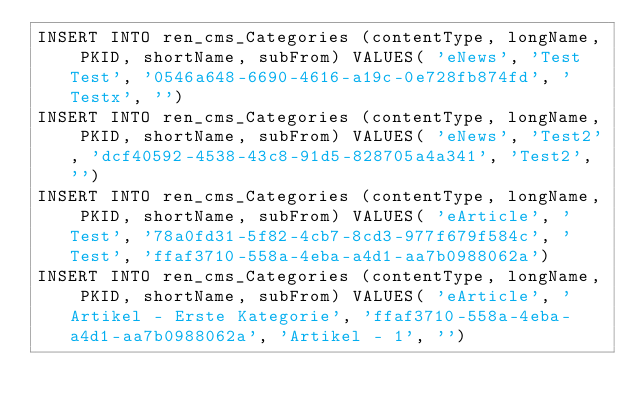Convert code to text. <code><loc_0><loc_0><loc_500><loc_500><_SQL_>INSERT INTO ren_cms_Categories (contentType, longName, PKID, shortName, subFrom) VALUES( 'eNews', 'Test Test', '0546a648-6690-4616-a19c-0e728fb874fd', 'Testx', '')
INSERT INTO ren_cms_Categories (contentType, longName, PKID, shortName, subFrom) VALUES( 'eNews', 'Test2', 'dcf40592-4538-43c8-91d5-828705a4a341', 'Test2', '')
INSERT INTO ren_cms_Categories (contentType, longName, PKID, shortName, subFrom) VALUES( 'eArticle', 'Test', '78a0fd31-5f82-4cb7-8cd3-977f679f584c', 'Test', 'ffaf3710-558a-4eba-a4d1-aa7b0988062a')
INSERT INTO ren_cms_Categories (contentType, longName, PKID, shortName, subFrom) VALUES( 'eArticle', 'Artikel - Erste Kategorie', 'ffaf3710-558a-4eba-a4d1-aa7b0988062a', 'Artikel - 1', '')
</code> 